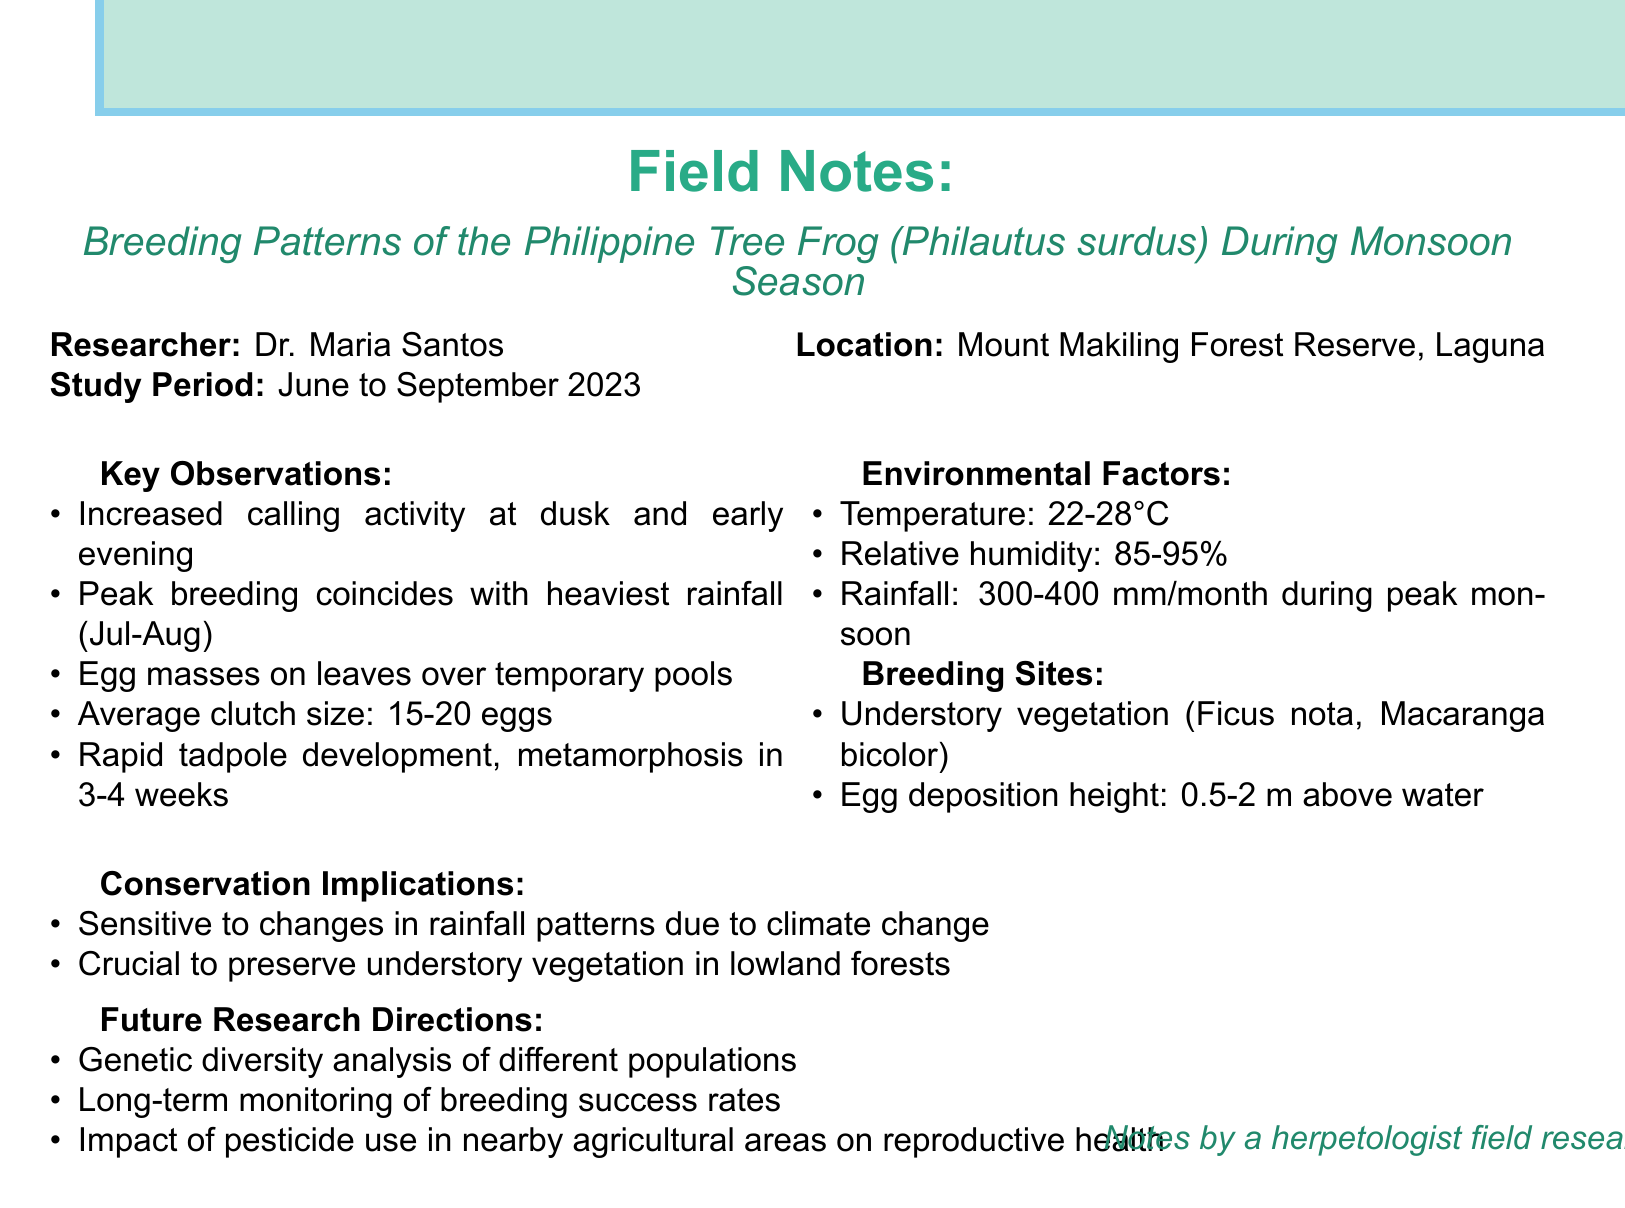What is the title of the study? The title is stated prominently at the beginning of the document detailing the subject of the research.
Answer: Breeding Patterns of the Philippine Tree Frog (Philautus surdus) During Monsoon Season Who conducted the research? The document attributes the research to a specific individual, indicating authorship of the study.
Answer: Dr. Maria Santos What is the location of the study? The location of the research study is mentioned to provide contextual background about where the study took place.
Answer: Mount Makiling Forest Reserve, Laguna How long was the study period? The study period is explicitly mentioned in the document, indicating the specific months during which observations were made.
Answer: June to September 2023 What is the average clutch size of the frog? This detail is provided as a key observation in the document, summarizing reproductive characteristics of the species.
Answer: 15-20 eggs What temperature range was recorded during the study? The document lists specific environmental factors, including the temperature range, important for understanding the habitat.
Answer: 22-28°C During which months did breeding peak? The peak breeding period is identified in the observations and corresponds with environmental conditions affecting reproduction.
Answer: July and August What is one conservation implication mentioned? The document discusses specific conservation concerns related to the study findings, highlighting the importance of certain environmental conditions.
Answer: Sensitivity to changes in rainfall patterns due to climate change What future research direction is suggested regarding pesticides? The document outlines suggested directions for future research, including the impact of agricultural practices on the species studied.
Answer: Impact of pesticide use in nearby agricultural areas on reproductive health 